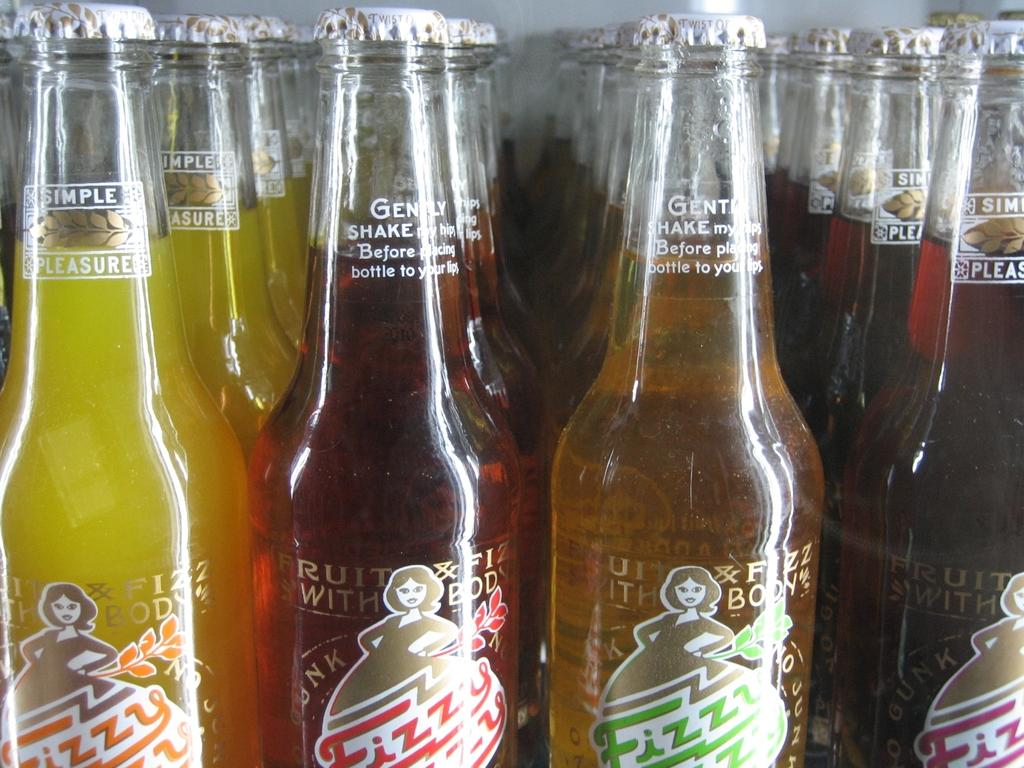<image>
Relay a brief, clear account of the picture shown. Fizzy fizzy makes several different flavors of soda. 